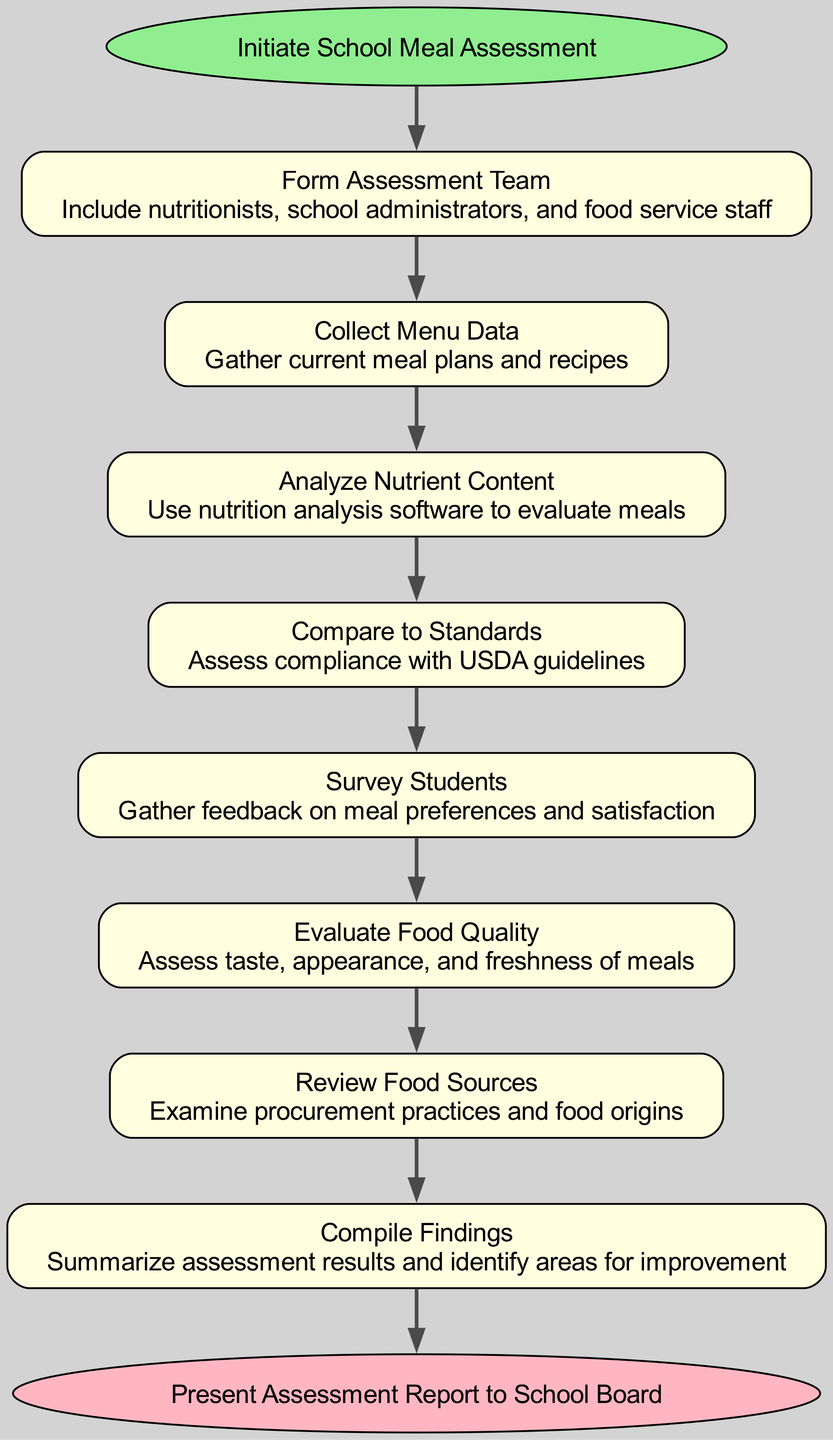What is the first step in the assessment process? The diagram starts with the node labeled "Initiate School Meal Assessment," which indicates that this is the first step in the process.
Answer: Initiate School Meal Assessment How many steps are there in total? By counting the number of nodes listed under the steps section, there are eight steps, including the start and end nodes.
Answer: Eight What is the final output of the assessment process? The last node of the diagram is labeled "Present Assessment Report to School Board," which signifies the final output of the process.
Answer: Present Assessment Report to School Board Which step involves gathering feedback from students? The step labeled "Survey Students" specifies that it involves gathering feedback on meal preferences and satisfaction.
Answer: Survey Students What does the analysis of nutrient content utilize? The step "Analyze Nutrient Content" mentions the use of nutrition analysis software, indicating this is the tool utilized for the analysis.
Answer: Nutrition analysis software What is the relationship between "Evaluate Food Quality" and "Review Food Sources"? "Evaluate Food Quality" and "Review Food Sources" are successive steps in the process, meaning one follows the other in the flow of the assessment.
Answer: Successive steps What key professionals should be included in the assessment team? The "Form Assessment Team" step details that nutritionists, school administrators, and food service staff are key professionals to include.
Answer: Nutritionists, school administrators, food service staff Which step comes directly after "Collect Menu Data"? The step that follows "Collect Menu Data" is "Analyze Nutrient Content," as indicated by the edges connecting these two nodes.
Answer: Analyze Nutrient Content How is compliance evaluated in the assessment? The step "Compare to Standards" explicitly states that compliance is assessed with USDA guidelines.
Answer: USDA guidelines 